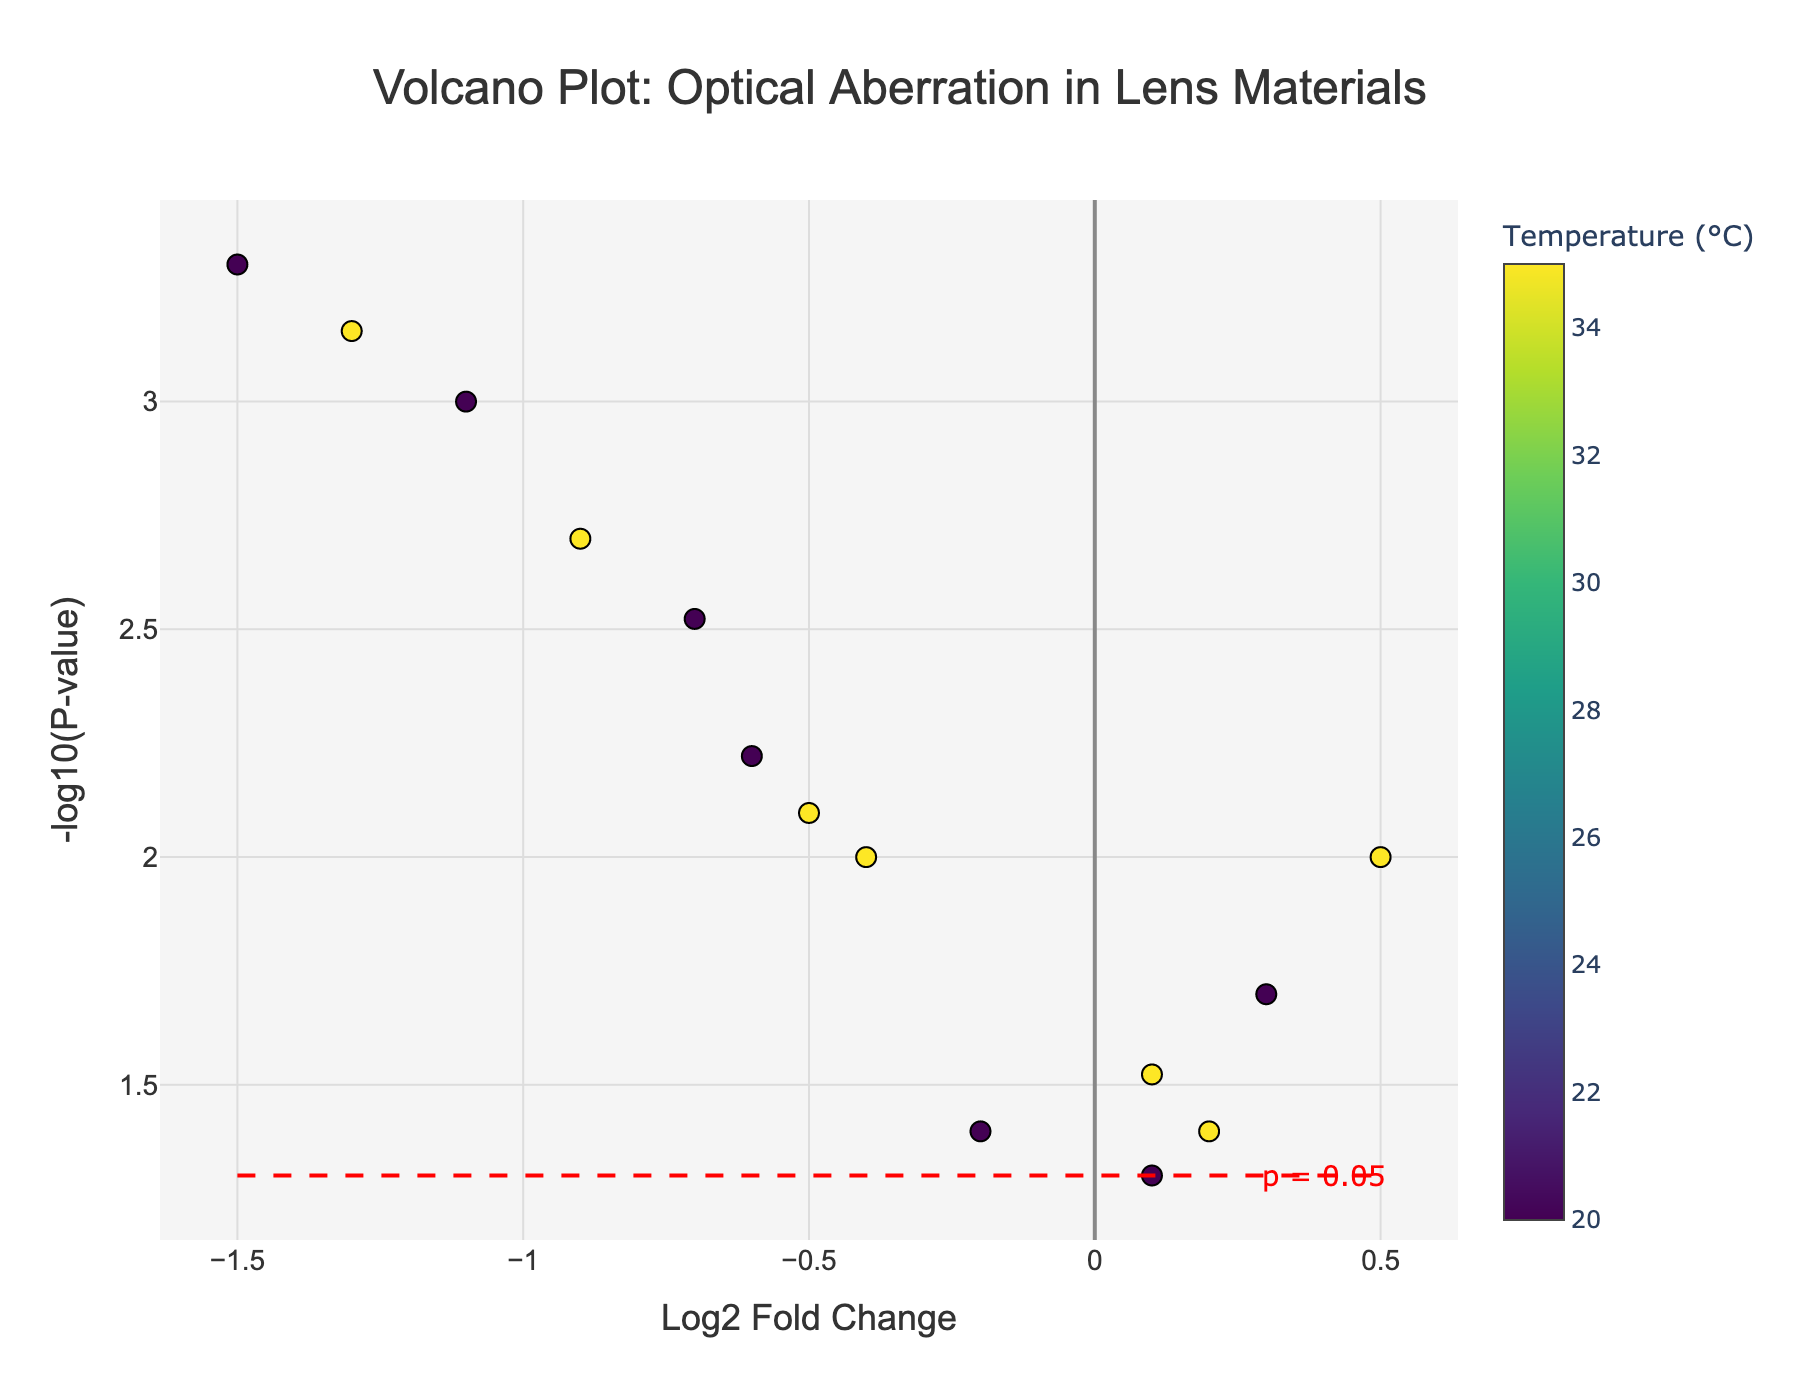Which material has the highest temperature? By examining the colorbar, we find that the highest temperature data points, represented with the darkest color, appear for several materials.
Answer: BK7 Glass, ED Glass, Fused Silica, Sapphire, Calcium Fluoride, Zerodur How many data points are plotted on the figure? Each point represents a unique combination of material type and temperature. By counting the total points, we find there are 14 data points.
Answer: 14 What is the title of the plot? The title is displayed at the top-center of the plot.
Answer: Volcano Plot: Optical Aberration in Lens Materials What is the range of Log2 Fold Change values represented? The x-axis represents Log2 Fold Change. By checking the extremes of the plot, the values range from -1.5 to 0.5.
Answer: -1.5 to 0.5 Which material shows the most significant change given a small p-value? Smallest p-values are represented by the highest points on the y-axis. Sapphire at 20°C has the smallest p-value.
Answer: Sapphire (20°C) Which material has the lowest chromatic aberration at 20°C? On the plot, click on data points corresponding to 20°C to identify chromatic aberration values in the hover text. The lowest value occurs for Sapphire at 20°C.
Answer: Sapphire How many materials show a negative Log2 Fold Change at 35°C? Observing the data points corresponding to 35°C (warmer colors) on the left side of the y-axis (negative) reveals the count. Four materials show a negative Log2 Fold Change at 35°C: Fluorite, Fused Silica, Sapphire, and Calcium Fluoride.
Answer: 4 What's the significance cut-off level used in the figure? The significance line on the y-axis is annotated. The red dashed line marks the significance threshold, which corresponds to a p-value of 0.05.
Answer: 0.05 Compare the chromatic aberrations for Fused Silica at two different temperatures. By examining the hover data for Fused Silica at 20°C and 35°C, we see chromatic aberrations of 0.2 μm and 0.3 μm respectively. This indicates an increase of 0.1 μm when the temperature rises from 20°C to 35°C.
Answer: 0.2 μm (20°C) and 0.3 μm (35°C) Which material shows an increase in Log2 Fold Change with temperature? By comparing the Log2 Fold Change for each material at 20°C and 35°C, the materials with increased values are identified. BK7 Glass and Zerodur show an increase in Log2 Fold Change from 20°C to 35°C.
Answer: BK7 Glass, Zerodur 